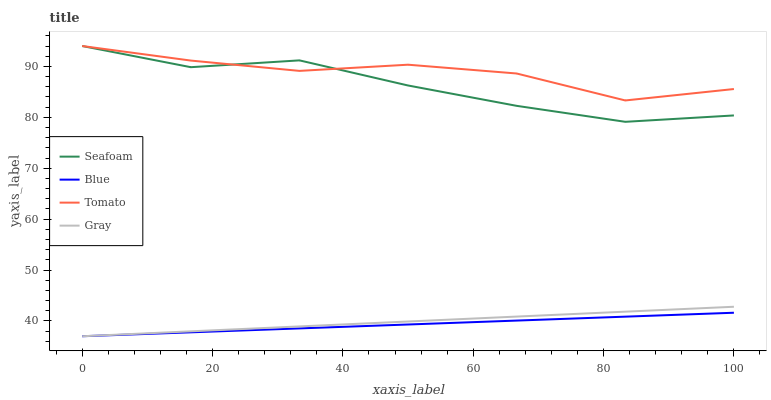Does Blue have the minimum area under the curve?
Answer yes or no. Yes. Does Tomato have the maximum area under the curve?
Answer yes or no. Yes. Does Seafoam have the minimum area under the curve?
Answer yes or no. No. Does Seafoam have the maximum area under the curve?
Answer yes or no. No. Is Gray the smoothest?
Answer yes or no. Yes. Is Tomato the roughest?
Answer yes or no. Yes. Is Seafoam the smoothest?
Answer yes or no. No. Is Seafoam the roughest?
Answer yes or no. No. Does Seafoam have the lowest value?
Answer yes or no. No. Does Gray have the highest value?
Answer yes or no. No. Is Gray less than Seafoam?
Answer yes or no. Yes. Is Seafoam greater than Gray?
Answer yes or no. Yes. Does Gray intersect Seafoam?
Answer yes or no. No. 